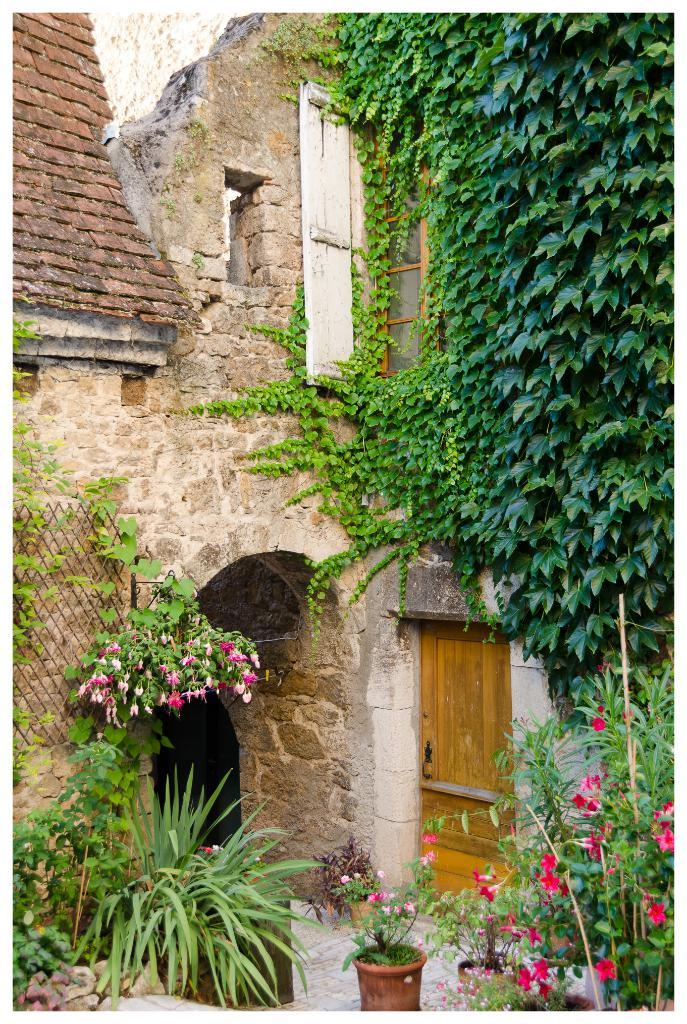What type of living organisms can be seen in the image? Plants and trees are visible in the image. What type of structure can be seen in the image? There is an architecture in the image. How long does it take for the jam to be spread on the tramp in the image? There is no tramp or jam present in the image. 